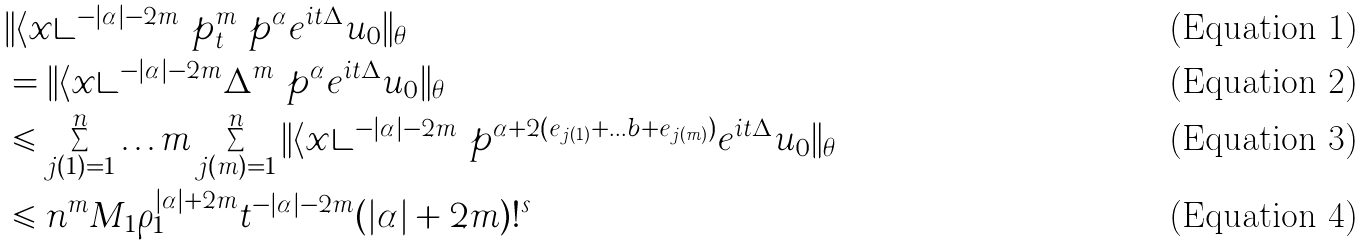<formula> <loc_0><loc_0><loc_500><loc_500>& \| \langle { x } \rangle ^ { - | \alpha | - 2 m } \ p _ { t } ^ { m } \ p ^ { \alpha } e ^ { i t \Delta } u _ { 0 } \| _ { \theta } \\ & = \| \langle { x } \rangle ^ { - | \alpha | - 2 m } \Delta ^ { m } \ p ^ { \alpha } e ^ { i t \Delta } u _ { 0 } \| _ { \theta } \\ & \leqslant \sum _ { j ( 1 ) = 1 } ^ { n } \dots m \sum _ { j ( m ) = 1 } ^ { n } \| \langle { x } \rangle ^ { - | \alpha | - 2 m } \ p ^ { \alpha + 2 ( e _ { j ( 1 ) } + \dots b + e _ { j ( m ) } ) } e ^ { i t \Delta } u _ { 0 } \| _ { \theta } \\ & \leqslant n ^ { m } M _ { 1 } \rho _ { 1 } ^ { | \alpha | + 2 m } t ^ { - | \alpha | - 2 m } ( | \alpha | + 2 m ) ! ^ { s }</formula> 